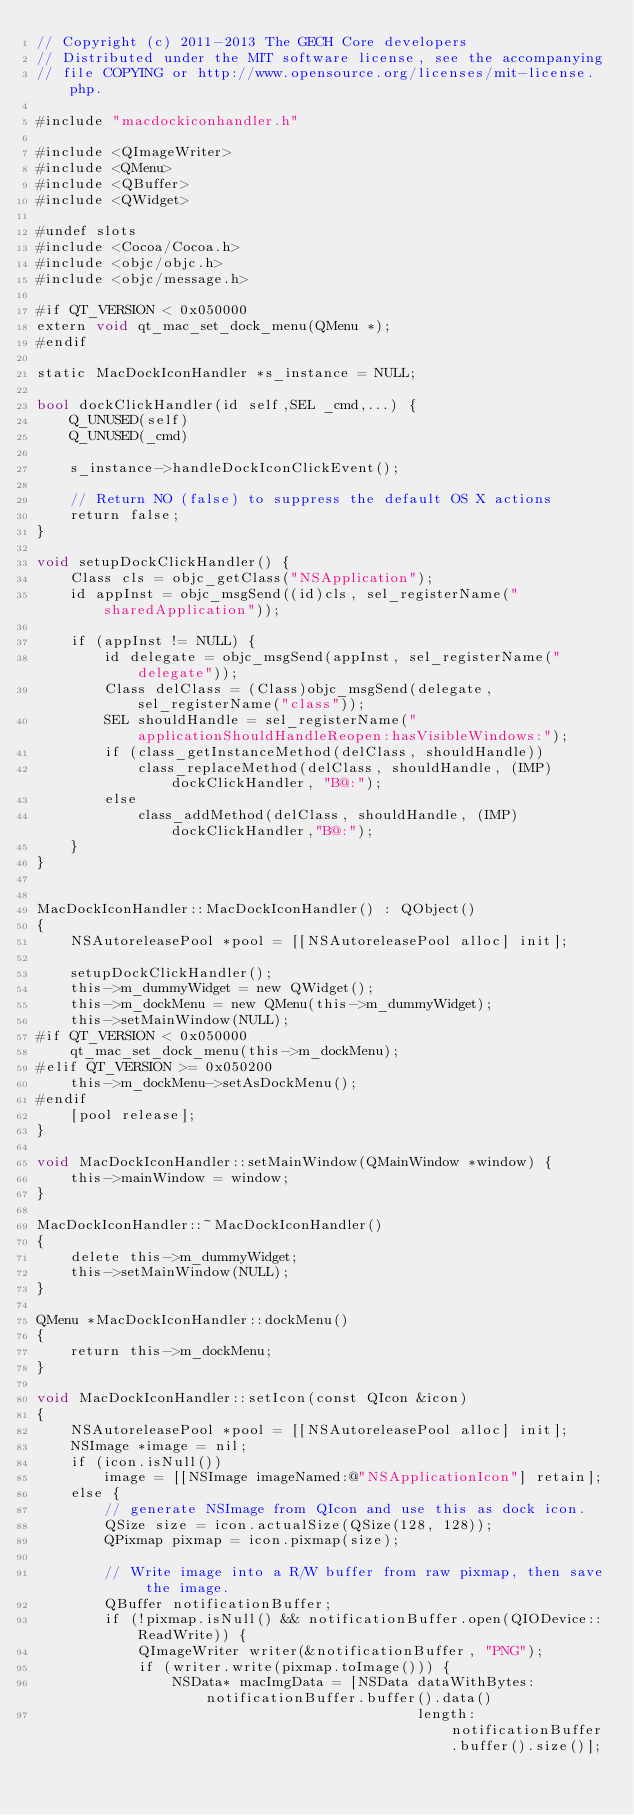<code> <loc_0><loc_0><loc_500><loc_500><_ObjectiveC_>// Copyright (c) 2011-2013 The GECH Core developers
// Distributed under the MIT software license, see the accompanying
// file COPYING or http://www.opensource.org/licenses/mit-license.php.

#include "macdockiconhandler.h"

#include <QImageWriter>
#include <QMenu>
#include <QBuffer>
#include <QWidget>

#undef slots
#include <Cocoa/Cocoa.h>
#include <objc/objc.h>
#include <objc/message.h>

#if QT_VERSION < 0x050000
extern void qt_mac_set_dock_menu(QMenu *);
#endif

static MacDockIconHandler *s_instance = NULL;

bool dockClickHandler(id self,SEL _cmd,...) {
    Q_UNUSED(self)
    Q_UNUSED(_cmd)
    
    s_instance->handleDockIconClickEvent();
    
    // Return NO (false) to suppress the default OS X actions
    return false;
}

void setupDockClickHandler() {
    Class cls = objc_getClass("NSApplication");
    id appInst = objc_msgSend((id)cls, sel_registerName("sharedApplication"));
    
    if (appInst != NULL) {
        id delegate = objc_msgSend(appInst, sel_registerName("delegate"));
        Class delClass = (Class)objc_msgSend(delegate,  sel_registerName("class"));
        SEL shouldHandle = sel_registerName("applicationShouldHandleReopen:hasVisibleWindows:");
        if (class_getInstanceMethod(delClass, shouldHandle))
            class_replaceMethod(delClass, shouldHandle, (IMP)dockClickHandler, "B@:");
        else
            class_addMethod(delClass, shouldHandle, (IMP)dockClickHandler,"B@:");
    }
}


MacDockIconHandler::MacDockIconHandler() : QObject()
{
    NSAutoreleasePool *pool = [[NSAutoreleasePool alloc] init];

    setupDockClickHandler();
    this->m_dummyWidget = new QWidget();
    this->m_dockMenu = new QMenu(this->m_dummyWidget);
    this->setMainWindow(NULL);
#if QT_VERSION < 0x050000
    qt_mac_set_dock_menu(this->m_dockMenu);
#elif QT_VERSION >= 0x050200
    this->m_dockMenu->setAsDockMenu();
#endif
    [pool release];
}

void MacDockIconHandler::setMainWindow(QMainWindow *window) {
    this->mainWindow = window;
}

MacDockIconHandler::~MacDockIconHandler()
{
    delete this->m_dummyWidget;
    this->setMainWindow(NULL);
}

QMenu *MacDockIconHandler::dockMenu()
{
    return this->m_dockMenu;
}

void MacDockIconHandler::setIcon(const QIcon &icon)
{
    NSAutoreleasePool *pool = [[NSAutoreleasePool alloc] init];
    NSImage *image = nil;
    if (icon.isNull())
        image = [[NSImage imageNamed:@"NSApplicationIcon"] retain];
    else {
        // generate NSImage from QIcon and use this as dock icon.
        QSize size = icon.actualSize(QSize(128, 128));
        QPixmap pixmap = icon.pixmap(size);

        // Write image into a R/W buffer from raw pixmap, then save the image.
        QBuffer notificationBuffer;
        if (!pixmap.isNull() && notificationBuffer.open(QIODevice::ReadWrite)) {
            QImageWriter writer(&notificationBuffer, "PNG");
            if (writer.write(pixmap.toImage())) {
                NSData* macImgData = [NSData dataWithBytes:notificationBuffer.buffer().data()
                                             length:notificationBuffer.buffer().size()];</code> 